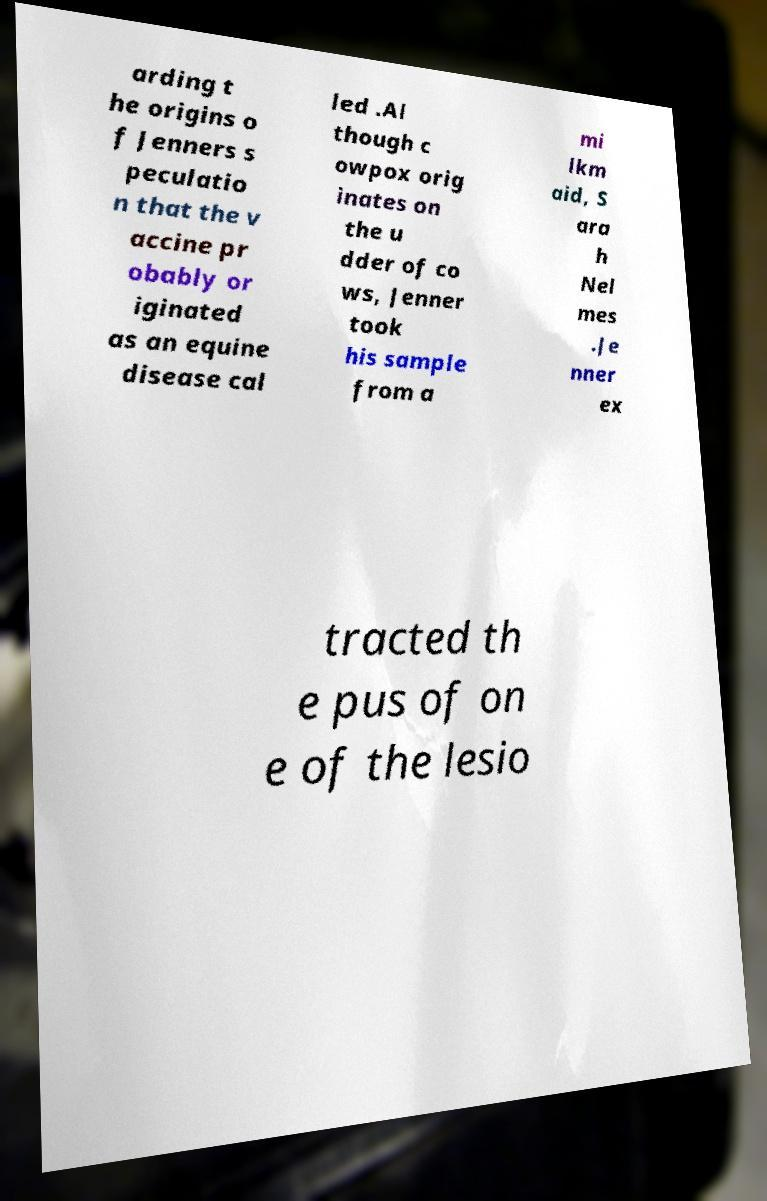Can you accurately transcribe the text from the provided image for me? arding t he origins o f Jenners s peculatio n that the v accine pr obably or iginated as an equine disease cal led .Al though c owpox orig inates on the u dder of co ws, Jenner took his sample from a mi lkm aid, S ara h Nel mes .Je nner ex tracted th e pus of on e of the lesio 